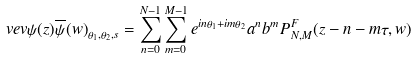Convert formula to latex. <formula><loc_0><loc_0><loc_500><loc_500>\ v e v { \psi ( z ) \overline { \psi } ( w ) } _ { \theta _ { 1 } , \theta _ { 2 } , s } = \sum _ { n = 0 } ^ { N - 1 } \sum _ { m = 0 } ^ { M - 1 } e ^ { i n \theta _ { 1 } + i m \theta _ { 2 } } a ^ { n } b ^ { m } P ^ { F } _ { N , M } ( z - n - m \tau , w )</formula> 